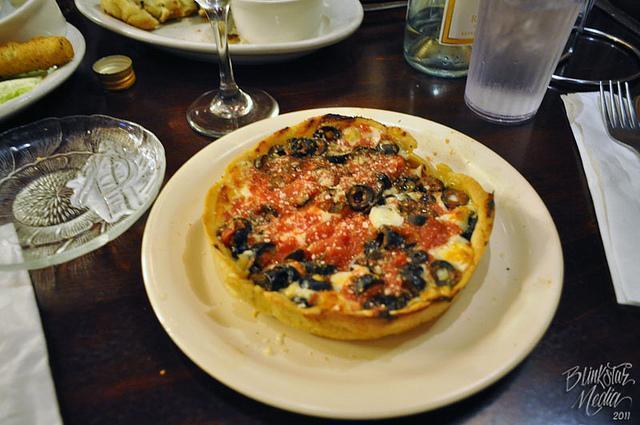Does the image validate the caption "The bowl is left of the pizza."?
Answer yes or no. Yes. 